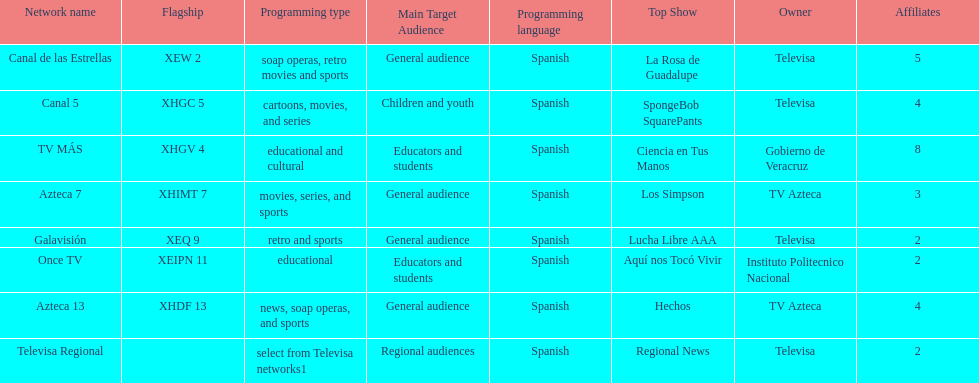Tell me the number of stations tv azteca owns. 2. 